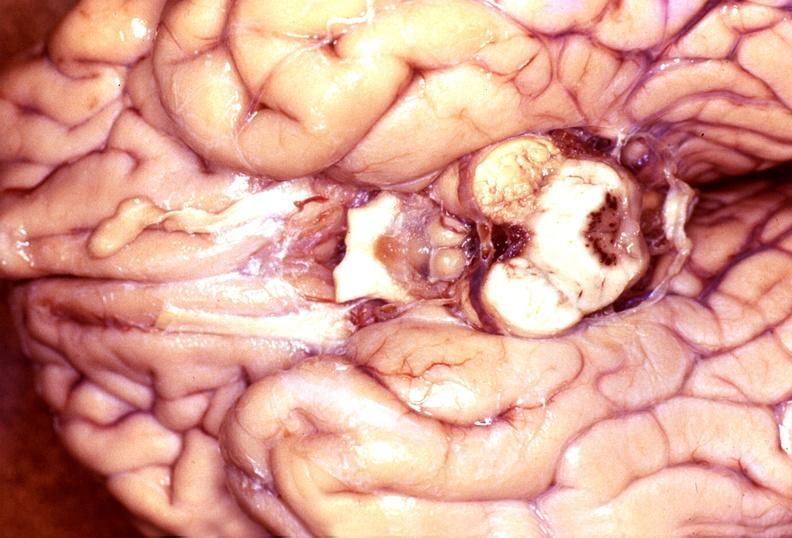s the tumor present?
Answer the question using a single word or phrase. No 